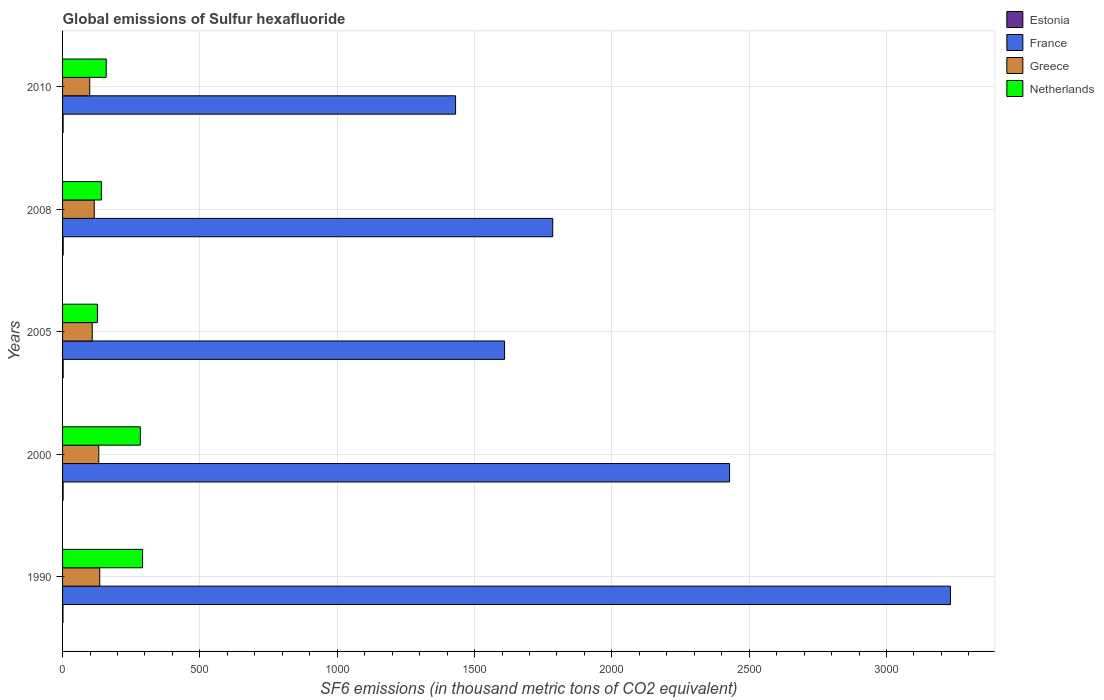How many bars are there on the 1st tick from the top?
Provide a short and direct response. 4. How many bars are there on the 1st tick from the bottom?
Your response must be concise. 4. In how many cases, is the number of bars for a given year not equal to the number of legend labels?
Provide a succinct answer. 0. What is the global emissions of Sulfur hexafluoride in Greece in 2010?
Give a very brief answer. 99. Across all years, what is the maximum global emissions of Sulfur hexafluoride in Estonia?
Your answer should be compact. 2.3. Across all years, what is the minimum global emissions of Sulfur hexafluoride in Greece?
Keep it short and to the point. 99. What is the total global emissions of Sulfur hexafluoride in France in the graph?
Your answer should be very brief. 1.05e+04. What is the difference between the global emissions of Sulfur hexafluoride in Estonia in 2005 and that in 2010?
Keep it short and to the point. 0.2. What is the difference between the global emissions of Sulfur hexafluoride in Netherlands in 2010 and the global emissions of Sulfur hexafluoride in France in 2000?
Make the answer very short. -2269.5. What is the average global emissions of Sulfur hexafluoride in Netherlands per year?
Your response must be concise. 200.32. In the year 2008, what is the difference between the global emissions of Sulfur hexafluoride in Netherlands and global emissions of Sulfur hexafluoride in Estonia?
Your answer should be very brief. 139.1. In how many years, is the global emissions of Sulfur hexafluoride in Estonia greater than 200 thousand metric tons?
Give a very brief answer. 0. What is the ratio of the global emissions of Sulfur hexafluoride in Estonia in 1990 to that in 2000?
Provide a short and direct response. 0.8. Is the global emissions of Sulfur hexafluoride in France in 1990 less than that in 2008?
Your answer should be compact. No. What is the difference between the highest and the second highest global emissions of Sulfur hexafluoride in Netherlands?
Provide a short and direct response. 8.3. What is the difference between the highest and the lowest global emissions of Sulfur hexafluoride in France?
Offer a terse response. 1801.8. In how many years, is the global emissions of Sulfur hexafluoride in France greater than the average global emissions of Sulfur hexafluoride in France taken over all years?
Provide a short and direct response. 2. What does the 4th bar from the top in 1990 represents?
Ensure brevity in your answer.  Estonia. What does the 1st bar from the bottom in 2005 represents?
Keep it short and to the point. Estonia. Is it the case that in every year, the sum of the global emissions of Sulfur hexafluoride in Estonia and global emissions of Sulfur hexafluoride in France is greater than the global emissions of Sulfur hexafluoride in Greece?
Your answer should be very brief. Yes. How many bars are there?
Offer a terse response. 20. How many years are there in the graph?
Provide a short and direct response. 5. Are the values on the major ticks of X-axis written in scientific E-notation?
Make the answer very short. No. Does the graph contain any zero values?
Make the answer very short. No. Does the graph contain grids?
Keep it short and to the point. Yes. Where does the legend appear in the graph?
Your response must be concise. Top right. How many legend labels are there?
Provide a short and direct response. 4. How are the legend labels stacked?
Give a very brief answer. Vertical. What is the title of the graph?
Provide a succinct answer. Global emissions of Sulfur hexafluoride. Does "Italy" appear as one of the legend labels in the graph?
Offer a very short reply. No. What is the label or title of the X-axis?
Offer a very short reply. SF6 emissions (in thousand metric tons of CO2 equivalent). What is the SF6 emissions (in thousand metric tons of CO2 equivalent) in France in 1990?
Offer a very short reply. 3232.8. What is the SF6 emissions (in thousand metric tons of CO2 equivalent) of Greece in 1990?
Your answer should be compact. 135.4. What is the SF6 emissions (in thousand metric tons of CO2 equivalent) of Netherlands in 1990?
Make the answer very short. 291.3. What is the SF6 emissions (in thousand metric tons of CO2 equivalent) of France in 2000?
Your answer should be very brief. 2428.5. What is the SF6 emissions (in thousand metric tons of CO2 equivalent) of Greece in 2000?
Your answer should be compact. 131.8. What is the SF6 emissions (in thousand metric tons of CO2 equivalent) in Netherlands in 2000?
Offer a very short reply. 283. What is the SF6 emissions (in thousand metric tons of CO2 equivalent) of Estonia in 2005?
Give a very brief answer. 2.2. What is the SF6 emissions (in thousand metric tons of CO2 equivalent) in France in 2005?
Provide a short and direct response. 1609.4. What is the SF6 emissions (in thousand metric tons of CO2 equivalent) of Greece in 2005?
Provide a short and direct response. 108.1. What is the SF6 emissions (in thousand metric tons of CO2 equivalent) of Netherlands in 2005?
Ensure brevity in your answer.  126.9. What is the SF6 emissions (in thousand metric tons of CO2 equivalent) of France in 2008?
Keep it short and to the point. 1784.7. What is the SF6 emissions (in thousand metric tons of CO2 equivalent) of Greece in 2008?
Offer a terse response. 115.4. What is the SF6 emissions (in thousand metric tons of CO2 equivalent) of Netherlands in 2008?
Provide a short and direct response. 141.4. What is the SF6 emissions (in thousand metric tons of CO2 equivalent) of France in 2010?
Your answer should be compact. 1431. What is the SF6 emissions (in thousand metric tons of CO2 equivalent) of Greece in 2010?
Your response must be concise. 99. What is the SF6 emissions (in thousand metric tons of CO2 equivalent) in Netherlands in 2010?
Keep it short and to the point. 159. Across all years, what is the maximum SF6 emissions (in thousand metric tons of CO2 equivalent) in France?
Ensure brevity in your answer.  3232.8. Across all years, what is the maximum SF6 emissions (in thousand metric tons of CO2 equivalent) in Greece?
Provide a short and direct response. 135.4. Across all years, what is the maximum SF6 emissions (in thousand metric tons of CO2 equivalent) in Netherlands?
Offer a very short reply. 291.3. Across all years, what is the minimum SF6 emissions (in thousand metric tons of CO2 equivalent) in France?
Make the answer very short. 1431. Across all years, what is the minimum SF6 emissions (in thousand metric tons of CO2 equivalent) in Greece?
Keep it short and to the point. 99. Across all years, what is the minimum SF6 emissions (in thousand metric tons of CO2 equivalent) of Netherlands?
Keep it short and to the point. 126.9. What is the total SF6 emissions (in thousand metric tons of CO2 equivalent) of France in the graph?
Offer a very short reply. 1.05e+04. What is the total SF6 emissions (in thousand metric tons of CO2 equivalent) in Greece in the graph?
Provide a short and direct response. 589.7. What is the total SF6 emissions (in thousand metric tons of CO2 equivalent) in Netherlands in the graph?
Provide a succinct answer. 1001.6. What is the difference between the SF6 emissions (in thousand metric tons of CO2 equivalent) in France in 1990 and that in 2000?
Offer a terse response. 804.3. What is the difference between the SF6 emissions (in thousand metric tons of CO2 equivalent) in Netherlands in 1990 and that in 2000?
Your answer should be compact. 8.3. What is the difference between the SF6 emissions (in thousand metric tons of CO2 equivalent) in Estonia in 1990 and that in 2005?
Your answer should be very brief. -0.6. What is the difference between the SF6 emissions (in thousand metric tons of CO2 equivalent) in France in 1990 and that in 2005?
Provide a succinct answer. 1623.4. What is the difference between the SF6 emissions (in thousand metric tons of CO2 equivalent) of Greece in 1990 and that in 2005?
Make the answer very short. 27.3. What is the difference between the SF6 emissions (in thousand metric tons of CO2 equivalent) of Netherlands in 1990 and that in 2005?
Ensure brevity in your answer.  164.4. What is the difference between the SF6 emissions (in thousand metric tons of CO2 equivalent) of Estonia in 1990 and that in 2008?
Your answer should be compact. -0.7. What is the difference between the SF6 emissions (in thousand metric tons of CO2 equivalent) of France in 1990 and that in 2008?
Offer a very short reply. 1448.1. What is the difference between the SF6 emissions (in thousand metric tons of CO2 equivalent) of Greece in 1990 and that in 2008?
Make the answer very short. 20. What is the difference between the SF6 emissions (in thousand metric tons of CO2 equivalent) of Netherlands in 1990 and that in 2008?
Make the answer very short. 149.9. What is the difference between the SF6 emissions (in thousand metric tons of CO2 equivalent) of France in 1990 and that in 2010?
Offer a terse response. 1801.8. What is the difference between the SF6 emissions (in thousand metric tons of CO2 equivalent) of Greece in 1990 and that in 2010?
Your answer should be very brief. 36.4. What is the difference between the SF6 emissions (in thousand metric tons of CO2 equivalent) in Netherlands in 1990 and that in 2010?
Your response must be concise. 132.3. What is the difference between the SF6 emissions (in thousand metric tons of CO2 equivalent) of France in 2000 and that in 2005?
Ensure brevity in your answer.  819.1. What is the difference between the SF6 emissions (in thousand metric tons of CO2 equivalent) of Greece in 2000 and that in 2005?
Keep it short and to the point. 23.7. What is the difference between the SF6 emissions (in thousand metric tons of CO2 equivalent) in Netherlands in 2000 and that in 2005?
Offer a terse response. 156.1. What is the difference between the SF6 emissions (in thousand metric tons of CO2 equivalent) of France in 2000 and that in 2008?
Keep it short and to the point. 643.8. What is the difference between the SF6 emissions (in thousand metric tons of CO2 equivalent) in Greece in 2000 and that in 2008?
Keep it short and to the point. 16.4. What is the difference between the SF6 emissions (in thousand metric tons of CO2 equivalent) in Netherlands in 2000 and that in 2008?
Ensure brevity in your answer.  141.6. What is the difference between the SF6 emissions (in thousand metric tons of CO2 equivalent) of Estonia in 2000 and that in 2010?
Provide a short and direct response. 0. What is the difference between the SF6 emissions (in thousand metric tons of CO2 equivalent) of France in 2000 and that in 2010?
Give a very brief answer. 997.5. What is the difference between the SF6 emissions (in thousand metric tons of CO2 equivalent) in Greece in 2000 and that in 2010?
Provide a short and direct response. 32.8. What is the difference between the SF6 emissions (in thousand metric tons of CO2 equivalent) of Netherlands in 2000 and that in 2010?
Offer a very short reply. 124. What is the difference between the SF6 emissions (in thousand metric tons of CO2 equivalent) in Estonia in 2005 and that in 2008?
Your response must be concise. -0.1. What is the difference between the SF6 emissions (in thousand metric tons of CO2 equivalent) in France in 2005 and that in 2008?
Keep it short and to the point. -175.3. What is the difference between the SF6 emissions (in thousand metric tons of CO2 equivalent) of Greece in 2005 and that in 2008?
Your response must be concise. -7.3. What is the difference between the SF6 emissions (in thousand metric tons of CO2 equivalent) of Estonia in 2005 and that in 2010?
Provide a succinct answer. 0.2. What is the difference between the SF6 emissions (in thousand metric tons of CO2 equivalent) in France in 2005 and that in 2010?
Make the answer very short. 178.4. What is the difference between the SF6 emissions (in thousand metric tons of CO2 equivalent) of Netherlands in 2005 and that in 2010?
Your answer should be compact. -32.1. What is the difference between the SF6 emissions (in thousand metric tons of CO2 equivalent) in Estonia in 2008 and that in 2010?
Give a very brief answer. 0.3. What is the difference between the SF6 emissions (in thousand metric tons of CO2 equivalent) in France in 2008 and that in 2010?
Your answer should be very brief. 353.7. What is the difference between the SF6 emissions (in thousand metric tons of CO2 equivalent) of Greece in 2008 and that in 2010?
Ensure brevity in your answer.  16.4. What is the difference between the SF6 emissions (in thousand metric tons of CO2 equivalent) in Netherlands in 2008 and that in 2010?
Your answer should be compact. -17.6. What is the difference between the SF6 emissions (in thousand metric tons of CO2 equivalent) of Estonia in 1990 and the SF6 emissions (in thousand metric tons of CO2 equivalent) of France in 2000?
Offer a very short reply. -2426.9. What is the difference between the SF6 emissions (in thousand metric tons of CO2 equivalent) in Estonia in 1990 and the SF6 emissions (in thousand metric tons of CO2 equivalent) in Greece in 2000?
Make the answer very short. -130.2. What is the difference between the SF6 emissions (in thousand metric tons of CO2 equivalent) of Estonia in 1990 and the SF6 emissions (in thousand metric tons of CO2 equivalent) of Netherlands in 2000?
Give a very brief answer. -281.4. What is the difference between the SF6 emissions (in thousand metric tons of CO2 equivalent) in France in 1990 and the SF6 emissions (in thousand metric tons of CO2 equivalent) in Greece in 2000?
Offer a very short reply. 3101. What is the difference between the SF6 emissions (in thousand metric tons of CO2 equivalent) in France in 1990 and the SF6 emissions (in thousand metric tons of CO2 equivalent) in Netherlands in 2000?
Your answer should be compact. 2949.8. What is the difference between the SF6 emissions (in thousand metric tons of CO2 equivalent) of Greece in 1990 and the SF6 emissions (in thousand metric tons of CO2 equivalent) of Netherlands in 2000?
Ensure brevity in your answer.  -147.6. What is the difference between the SF6 emissions (in thousand metric tons of CO2 equivalent) in Estonia in 1990 and the SF6 emissions (in thousand metric tons of CO2 equivalent) in France in 2005?
Ensure brevity in your answer.  -1607.8. What is the difference between the SF6 emissions (in thousand metric tons of CO2 equivalent) in Estonia in 1990 and the SF6 emissions (in thousand metric tons of CO2 equivalent) in Greece in 2005?
Your response must be concise. -106.5. What is the difference between the SF6 emissions (in thousand metric tons of CO2 equivalent) in Estonia in 1990 and the SF6 emissions (in thousand metric tons of CO2 equivalent) in Netherlands in 2005?
Provide a short and direct response. -125.3. What is the difference between the SF6 emissions (in thousand metric tons of CO2 equivalent) in France in 1990 and the SF6 emissions (in thousand metric tons of CO2 equivalent) in Greece in 2005?
Ensure brevity in your answer.  3124.7. What is the difference between the SF6 emissions (in thousand metric tons of CO2 equivalent) in France in 1990 and the SF6 emissions (in thousand metric tons of CO2 equivalent) in Netherlands in 2005?
Provide a short and direct response. 3105.9. What is the difference between the SF6 emissions (in thousand metric tons of CO2 equivalent) of Estonia in 1990 and the SF6 emissions (in thousand metric tons of CO2 equivalent) of France in 2008?
Your response must be concise. -1783.1. What is the difference between the SF6 emissions (in thousand metric tons of CO2 equivalent) in Estonia in 1990 and the SF6 emissions (in thousand metric tons of CO2 equivalent) in Greece in 2008?
Provide a short and direct response. -113.8. What is the difference between the SF6 emissions (in thousand metric tons of CO2 equivalent) in Estonia in 1990 and the SF6 emissions (in thousand metric tons of CO2 equivalent) in Netherlands in 2008?
Give a very brief answer. -139.8. What is the difference between the SF6 emissions (in thousand metric tons of CO2 equivalent) of France in 1990 and the SF6 emissions (in thousand metric tons of CO2 equivalent) of Greece in 2008?
Offer a terse response. 3117.4. What is the difference between the SF6 emissions (in thousand metric tons of CO2 equivalent) of France in 1990 and the SF6 emissions (in thousand metric tons of CO2 equivalent) of Netherlands in 2008?
Make the answer very short. 3091.4. What is the difference between the SF6 emissions (in thousand metric tons of CO2 equivalent) in Estonia in 1990 and the SF6 emissions (in thousand metric tons of CO2 equivalent) in France in 2010?
Offer a very short reply. -1429.4. What is the difference between the SF6 emissions (in thousand metric tons of CO2 equivalent) of Estonia in 1990 and the SF6 emissions (in thousand metric tons of CO2 equivalent) of Greece in 2010?
Your answer should be compact. -97.4. What is the difference between the SF6 emissions (in thousand metric tons of CO2 equivalent) of Estonia in 1990 and the SF6 emissions (in thousand metric tons of CO2 equivalent) of Netherlands in 2010?
Your response must be concise. -157.4. What is the difference between the SF6 emissions (in thousand metric tons of CO2 equivalent) in France in 1990 and the SF6 emissions (in thousand metric tons of CO2 equivalent) in Greece in 2010?
Give a very brief answer. 3133.8. What is the difference between the SF6 emissions (in thousand metric tons of CO2 equivalent) of France in 1990 and the SF6 emissions (in thousand metric tons of CO2 equivalent) of Netherlands in 2010?
Keep it short and to the point. 3073.8. What is the difference between the SF6 emissions (in thousand metric tons of CO2 equivalent) of Greece in 1990 and the SF6 emissions (in thousand metric tons of CO2 equivalent) of Netherlands in 2010?
Your answer should be very brief. -23.6. What is the difference between the SF6 emissions (in thousand metric tons of CO2 equivalent) of Estonia in 2000 and the SF6 emissions (in thousand metric tons of CO2 equivalent) of France in 2005?
Offer a terse response. -1607.4. What is the difference between the SF6 emissions (in thousand metric tons of CO2 equivalent) in Estonia in 2000 and the SF6 emissions (in thousand metric tons of CO2 equivalent) in Greece in 2005?
Offer a very short reply. -106.1. What is the difference between the SF6 emissions (in thousand metric tons of CO2 equivalent) in Estonia in 2000 and the SF6 emissions (in thousand metric tons of CO2 equivalent) in Netherlands in 2005?
Offer a terse response. -124.9. What is the difference between the SF6 emissions (in thousand metric tons of CO2 equivalent) in France in 2000 and the SF6 emissions (in thousand metric tons of CO2 equivalent) in Greece in 2005?
Your response must be concise. 2320.4. What is the difference between the SF6 emissions (in thousand metric tons of CO2 equivalent) in France in 2000 and the SF6 emissions (in thousand metric tons of CO2 equivalent) in Netherlands in 2005?
Provide a succinct answer. 2301.6. What is the difference between the SF6 emissions (in thousand metric tons of CO2 equivalent) in Greece in 2000 and the SF6 emissions (in thousand metric tons of CO2 equivalent) in Netherlands in 2005?
Your answer should be very brief. 4.9. What is the difference between the SF6 emissions (in thousand metric tons of CO2 equivalent) in Estonia in 2000 and the SF6 emissions (in thousand metric tons of CO2 equivalent) in France in 2008?
Your response must be concise. -1782.7. What is the difference between the SF6 emissions (in thousand metric tons of CO2 equivalent) in Estonia in 2000 and the SF6 emissions (in thousand metric tons of CO2 equivalent) in Greece in 2008?
Ensure brevity in your answer.  -113.4. What is the difference between the SF6 emissions (in thousand metric tons of CO2 equivalent) of Estonia in 2000 and the SF6 emissions (in thousand metric tons of CO2 equivalent) of Netherlands in 2008?
Make the answer very short. -139.4. What is the difference between the SF6 emissions (in thousand metric tons of CO2 equivalent) of France in 2000 and the SF6 emissions (in thousand metric tons of CO2 equivalent) of Greece in 2008?
Ensure brevity in your answer.  2313.1. What is the difference between the SF6 emissions (in thousand metric tons of CO2 equivalent) of France in 2000 and the SF6 emissions (in thousand metric tons of CO2 equivalent) of Netherlands in 2008?
Make the answer very short. 2287.1. What is the difference between the SF6 emissions (in thousand metric tons of CO2 equivalent) of Estonia in 2000 and the SF6 emissions (in thousand metric tons of CO2 equivalent) of France in 2010?
Your answer should be very brief. -1429. What is the difference between the SF6 emissions (in thousand metric tons of CO2 equivalent) in Estonia in 2000 and the SF6 emissions (in thousand metric tons of CO2 equivalent) in Greece in 2010?
Provide a short and direct response. -97. What is the difference between the SF6 emissions (in thousand metric tons of CO2 equivalent) in Estonia in 2000 and the SF6 emissions (in thousand metric tons of CO2 equivalent) in Netherlands in 2010?
Make the answer very short. -157. What is the difference between the SF6 emissions (in thousand metric tons of CO2 equivalent) in France in 2000 and the SF6 emissions (in thousand metric tons of CO2 equivalent) in Greece in 2010?
Provide a short and direct response. 2329.5. What is the difference between the SF6 emissions (in thousand metric tons of CO2 equivalent) in France in 2000 and the SF6 emissions (in thousand metric tons of CO2 equivalent) in Netherlands in 2010?
Your response must be concise. 2269.5. What is the difference between the SF6 emissions (in thousand metric tons of CO2 equivalent) of Greece in 2000 and the SF6 emissions (in thousand metric tons of CO2 equivalent) of Netherlands in 2010?
Ensure brevity in your answer.  -27.2. What is the difference between the SF6 emissions (in thousand metric tons of CO2 equivalent) in Estonia in 2005 and the SF6 emissions (in thousand metric tons of CO2 equivalent) in France in 2008?
Keep it short and to the point. -1782.5. What is the difference between the SF6 emissions (in thousand metric tons of CO2 equivalent) of Estonia in 2005 and the SF6 emissions (in thousand metric tons of CO2 equivalent) of Greece in 2008?
Your answer should be compact. -113.2. What is the difference between the SF6 emissions (in thousand metric tons of CO2 equivalent) in Estonia in 2005 and the SF6 emissions (in thousand metric tons of CO2 equivalent) in Netherlands in 2008?
Offer a terse response. -139.2. What is the difference between the SF6 emissions (in thousand metric tons of CO2 equivalent) in France in 2005 and the SF6 emissions (in thousand metric tons of CO2 equivalent) in Greece in 2008?
Provide a succinct answer. 1494. What is the difference between the SF6 emissions (in thousand metric tons of CO2 equivalent) of France in 2005 and the SF6 emissions (in thousand metric tons of CO2 equivalent) of Netherlands in 2008?
Give a very brief answer. 1468. What is the difference between the SF6 emissions (in thousand metric tons of CO2 equivalent) in Greece in 2005 and the SF6 emissions (in thousand metric tons of CO2 equivalent) in Netherlands in 2008?
Ensure brevity in your answer.  -33.3. What is the difference between the SF6 emissions (in thousand metric tons of CO2 equivalent) of Estonia in 2005 and the SF6 emissions (in thousand metric tons of CO2 equivalent) of France in 2010?
Provide a short and direct response. -1428.8. What is the difference between the SF6 emissions (in thousand metric tons of CO2 equivalent) of Estonia in 2005 and the SF6 emissions (in thousand metric tons of CO2 equivalent) of Greece in 2010?
Offer a very short reply. -96.8. What is the difference between the SF6 emissions (in thousand metric tons of CO2 equivalent) in Estonia in 2005 and the SF6 emissions (in thousand metric tons of CO2 equivalent) in Netherlands in 2010?
Your response must be concise. -156.8. What is the difference between the SF6 emissions (in thousand metric tons of CO2 equivalent) in France in 2005 and the SF6 emissions (in thousand metric tons of CO2 equivalent) in Greece in 2010?
Offer a terse response. 1510.4. What is the difference between the SF6 emissions (in thousand metric tons of CO2 equivalent) in France in 2005 and the SF6 emissions (in thousand metric tons of CO2 equivalent) in Netherlands in 2010?
Keep it short and to the point. 1450.4. What is the difference between the SF6 emissions (in thousand metric tons of CO2 equivalent) of Greece in 2005 and the SF6 emissions (in thousand metric tons of CO2 equivalent) of Netherlands in 2010?
Your answer should be very brief. -50.9. What is the difference between the SF6 emissions (in thousand metric tons of CO2 equivalent) in Estonia in 2008 and the SF6 emissions (in thousand metric tons of CO2 equivalent) in France in 2010?
Ensure brevity in your answer.  -1428.7. What is the difference between the SF6 emissions (in thousand metric tons of CO2 equivalent) of Estonia in 2008 and the SF6 emissions (in thousand metric tons of CO2 equivalent) of Greece in 2010?
Keep it short and to the point. -96.7. What is the difference between the SF6 emissions (in thousand metric tons of CO2 equivalent) of Estonia in 2008 and the SF6 emissions (in thousand metric tons of CO2 equivalent) of Netherlands in 2010?
Keep it short and to the point. -156.7. What is the difference between the SF6 emissions (in thousand metric tons of CO2 equivalent) in France in 2008 and the SF6 emissions (in thousand metric tons of CO2 equivalent) in Greece in 2010?
Provide a short and direct response. 1685.7. What is the difference between the SF6 emissions (in thousand metric tons of CO2 equivalent) of France in 2008 and the SF6 emissions (in thousand metric tons of CO2 equivalent) of Netherlands in 2010?
Give a very brief answer. 1625.7. What is the difference between the SF6 emissions (in thousand metric tons of CO2 equivalent) of Greece in 2008 and the SF6 emissions (in thousand metric tons of CO2 equivalent) of Netherlands in 2010?
Your answer should be very brief. -43.6. What is the average SF6 emissions (in thousand metric tons of CO2 equivalent) of Estonia per year?
Give a very brief answer. 2.02. What is the average SF6 emissions (in thousand metric tons of CO2 equivalent) of France per year?
Your response must be concise. 2097.28. What is the average SF6 emissions (in thousand metric tons of CO2 equivalent) of Greece per year?
Provide a short and direct response. 117.94. What is the average SF6 emissions (in thousand metric tons of CO2 equivalent) in Netherlands per year?
Keep it short and to the point. 200.32. In the year 1990, what is the difference between the SF6 emissions (in thousand metric tons of CO2 equivalent) in Estonia and SF6 emissions (in thousand metric tons of CO2 equivalent) in France?
Ensure brevity in your answer.  -3231.2. In the year 1990, what is the difference between the SF6 emissions (in thousand metric tons of CO2 equivalent) in Estonia and SF6 emissions (in thousand metric tons of CO2 equivalent) in Greece?
Give a very brief answer. -133.8. In the year 1990, what is the difference between the SF6 emissions (in thousand metric tons of CO2 equivalent) in Estonia and SF6 emissions (in thousand metric tons of CO2 equivalent) in Netherlands?
Ensure brevity in your answer.  -289.7. In the year 1990, what is the difference between the SF6 emissions (in thousand metric tons of CO2 equivalent) in France and SF6 emissions (in thousand metric tons of CO2 equivalent) in Greece?
Offer a very short reply. 3097.4. In the year 1990, what is the difference between the SF6 emissions (in thousand metric tons of CO2 equivalent) of France and SF6 emissions (in thousand metric tons of CO2 equivalent) of Netherlands?
Offer a very short reply. 2941.5. In the year 1990, what is the difference between the SF6 emissions (in thousand metric tons of CO2 equivalent) in Greece and SF6 emissions (in thousand metric tons of CO2 equivalent) in Netherlands?
Ensure brevity in your answer.  -155.9. In the year 2000, what is the difference between the SF6 emissions (in thousand metric tons of CO2 equivalent) of Estonia and SF6 emissions (in thousand metric tons of CO2 equivalent) of France?
Keep it short and to the point. -2426.5. In the year 2000, what is the difference between the SF6 emissions (in thousand metric tons of CO2 equivalent) of Estonia and SF6 emissions (in thousand metric tons of CO2 equivalent) of Greece?
Provide a short and direct response. -129.8. In the year 2000, what is the difference between the SF6 emissions (in thousand metric tons of CO2 equivalent) in Estonia and SF6 emissions (in thousand metric tons of CO2 equivalent) in Netherlands?
Offer a terse response. -281. In the year 2000, what is the difference between the SF6 emissions (in thousand metric tons of CO2 equivalent) of France and SF6 emissions (in thousand metric tons of CO2 equivalent) of Greece?
Provide a short and direct response. 2296.7. In the year 2000, what is the difference between the SF6 emissions (in thousand metric tons of CO2 equivalent) in France and SF6 emissions (in thousand metric tons of CO2 equivalent) in Netherlands?
Offer a very short reply. 2145.5. In the year 2000, what is the difference between the SF6 emissions (in thousand metric tons of CO2 equivalent) in Greece and SF6 emissions (in thousand metric tons of CO2 equivalent) in Netherlands?
Your answer should be very brief. -151.2. In the year 2005, what is the difference between the SF6 emissions (in thousand metric tons of CO2 equivalent) of Estonia and SF6 emissions (in thousand metric tons of CO2 equivalent) of France?
Keep it short and to the point. -1607.2. In the year 2005, what is the difference between the SF6 emissions (in thousand metric tons of CO2 equivalent) of Estonia and SF6 emissions (in thousand metric tons of CO2 equivalent) of Greece?
Provide a succinct answer. -105.9. In the year 2005, what is the difference between the SF6 emissions (in thousand metric tons of CO2 equivalent) of Estonia and SF6 emissions (in thousand metric tons of CO2 equivalent) of Netherlands?
Ensure brevity in your answer.  -124.7. In the year 2005, what is the difference between the SF6 emissions (in thousand metric tons of CO2 equivalent) in France and SF6 emissions (in thousand metric tons of CO2 equivalent) in Greece?
Ensure brevity in your answer.  1501.3. In the year 2005, what is the difference between the SF6 emissions (in thousand metric tons of CO2 equivalent) of France and SF6 emissions (in thousand metric tons of CO2 equivalent) of Netherlands?
Give a very brief answer. 1482.5. In the year 2005, what is the difference between the SF6 emissions (in thousand metric tons of CO2 equivalent) in Greece and SF6 emissions (in thousand metric tons of CO2 equivalent) in Netherlands?
Give a very brief answer. -18.8. In the year 2008, what is the difference between the SF6 emissions (in thousand metric tons of CO2 equivalent) in Estonia and SF6 emissions (in thousand metric tons of CO2 equivalent) in France?
Offer a very short reply. -1782.4. In the year 2008, what is the difference between the SF6 emissions (in thousand metric tons of CO2 equivalent) in Estonia and SF6 emissions (in thousand metric tons of CO2 equivalent) in Greece?
Your response must be concise. -113.1. In the year 2008, what is the difference between the SF6 emissions (in thousand metric tons of CO2 equivalent) of Estonia and SF6 emissions (in thousand metric tons of CO2 equivalent) of Netherlands?
Offer a terse response. -139.1. In the year 2008, what is the difference between the SF6 emissions (in thousand metric tons of CO2 equivalent) in France and SF6 emissions (in thousand metric tons of CO2 equivalent) in Greece?
Your answer should be very brief. 1669.3. In the year 2008, what is the difference between the SF6 emissions (in thousand metric tons of CO2 equivalent) in France and SF6 emissions (in thousand metric tons of CO2 equivalent) in Netherlands?
Your response must be concise. 1643.3. In the year 2008, what is the difference between the SF6 emissions (in thousand metric tons of CO2 equivalent) in Greece and SF6 emissions (in thousand metric tons of CO2 equivalent) in Netherlands?
Provide a short and direct response. -26. In the year 2010, what is the difference between the SF6 emissions (in thousand metric tons of CO2 equivalent) of Estonia and SF6 emissions (in thousand metric tons of CO2 equivalent) of France?
Provide a succinct answer. -1429. In the year 2010, what is the difference between the SF6 emissions (in thousand metric tons of CO2 equivalent) of Estonia and SF6 emissions (in thousand metric tons of CO2 equivalent) of Greece?
Offer a very short reply. -97. In the year 2010, what is the difference between the SF6 emissions (in thousand metric tons of CO2 equivalent) of Estonia and SF6 emissions (in thousand metric tons of CO2 equivalent) of Netherlands?
Ensure brevity in your answer.  -157. In the year 2010, what is the difference between the SF6 emissions (in thousand metric tons of CO2 equivalent) in France and SF6 emissions (in thousand metric tons of CO2 equivalent) in Greece?
Ensure brevity in your answer.  1332. In the year 2010, what is the difference between the SF6 emissions (in thousand metric tons of CO2 equivalent) of France and SF6 emissions (in thousand metric tons of CO2 equivalent) of Netherlands?
Provide a short and direct response. 1272. In the year 2010, what is the difference between the SF6 emissions (in thousand metric tons of CO2 equivalent) in Greece and SF6 emissions (in thousand metric tons of CO2 equivalent) in Netherlands?
Ensure brevity in your answer.  -60. What is the ratio of the SF6 emissions (in thousand metric tons of CO2 equivalent) of Estonia in 1990 to that in 2000?
Ensure brevity in your answer.  0.8. What is the ratio of the SF6 emissions (in thousand metric tons of CO2 equivalent) of France in 1990 to that in 2000?
Give a very brief answer. 1.33. What is the ratio of the SF6 emissions (in thousand metric tons of CO2 equivalent) in Greece in 1990 to that in 2000?
Your answer should be very brief. 1.03. What is the ratio of the SF6 emissions (in thousand metric tons of CO2 equivalent) of Netherlands in 1990 to that in 2000?
Keep it short and to the point. 1.03. What is the ratio of the SF6 emissions (in thousand metric tons of CO2 equivalent) in Estonia in 1990 to that in 2005?
Make the answer very short. 0.73. What is the ratio of the SF6 emissions (in thousand metric tons of CO2 equivalent) of France in 1990 to that in 2005?
Your answer should be compact. 2.01. What is the ratio of the SF6 emissions (in thousand metric tons of CO2 equivalent) in Greece in 1990 to that in 2005?
Keep it short and to the point. 1.25. What is the ratio of the SF6 emissions (in thousand metric tons of CO2 equivalent) in Netherlands in 1990 to that in 2005?
Ensure brevity in your answer.  2.3. What is the ratio of the SF6 emissions (in thousand metric tons of CO2 equivalent) of Estonia in 1990 to that in 2008?
Your response must be concise. 0.7. What is the ratio of the SF6 emissions (in thousand metric tons of CO2 equivalent) in France in 1990 to that in 2008?
Provide a succinct answer. 1.81. What is the ratio of the SF6 emissions (in thousand metric tons of CO2 equivalent) of Greece in 1990 to that in 2008?
Offer a very short reply. 1.17. What is the ratio of the SF6 emissions (in thousand metric tons of CO2 equivalent) of Netherlands in 1990 to that in 2008?
Provide a succinct answer. 2.06. What is the ratio of the SF6 emissions (in thousand metric tons of CO2 equivalent) of France in 1990 to that in 2010?
Give a very brief answer. 2.26. What is the ratio of the SF6 emissions (in thousand metric tons of CO2 equivalent) of Greece in 1990 to that in 2010?
Your response must be concise. 1.37. What is the ratio of the SF6 emissions (in thousand metric tons of CO2 equivalent) in Netherlands in 1990 to that in 2010?
Keep it short and to the point. 1.83. What is the ratio of the SF6 emissions (in thousand metric tons of CO2 equivalent) in France in 2000 to that in 2005?
Your answer should be very brief. 1.51. What is the ratio of the SF6 emissions (in thousand metric tons of CO2 equivalent) in Greece in 2000 to that in 2005?
Your answer should be compact. 1.22. What is the ratio of the SF6 emissions (in thousand metric tons of CO2 equivalent) of Netherlands in 2000 to that in 2005?
Give a very brief answer. 2.23. What is the ratio of the SF6 emissions (in thousand metric tons of CO2 equivalent) in Estonia in 2000 to that in 2008?
Your response must be concise. 0.87. What is the ratio of the SF6 emissions (in thousand metric tons of CO2 equivalent) in France in 2000 to that in 2008?
Your response must be concise. 1.36. What is the ratio of the SF6 emissions (in thousand metric tons of CO2 equivalent) in Greece in 2000 to that in 2008?
Ensure brevity in your answer.  1.14. What is the ratio of the SF6 emissions (in thousand metric tons of CO2 equivalent) of Netherlands in 2000 to that in 2008?
Make the answer very short. 2. What is the ratio of the SF6 emissions (in thousand metric tons of CO2 equivalent) in Estonia in 2000 to that in 2010?
Your response must be concise. 1. What is the ratio of the SF6 emissions (in thousand metric tons of CO2 equivalent) of France in 2000 to that in 2010?
Your answer should be very brief. 1.7. What is the ratio of the SF6 emissions (in thousand metric tons of CO2 equivalent) of Greece in 2000 to that in 2010?
Your answer should be very brief. 1.33. What is the ratio of the SF6 emissions (in thousand metric tons of CO2 equivalent) of Netherlands in 2000 to that in 2010?
Your answer should be compact. 1.78. What is the ratio of the SF6 emissions (in thousand metric tons of CO2 equivalent) in Estonia in 2005 to that in 2008?
Provide a short and direct response. 0.96. What is the ratio of the SF6 emissions (in thousand metric tons of CO2 equivalent) in France in 2005 to that in 2008?
Offer a terse response. 0.9. What is the ratio of the SF6 emissions (in thousand metric tons of CO2 equivalent) of Greece in 2005 to that in 2008?
Your response must be concise. 0.94. What is the ratio of the SF6 emissions (in thousand metric tons of CO2 equivalent) of Netherlands in 2005 to that in 2008?
Keep it short and to the point. 0.9. What is the ratio of the SF6 emissions (in thousand metric tons of CO2 equivalent) of France in 2005 to that in 2010?
Your response must be concise. 1.12. What is the ratio of the SF6 emissions (in thousand metric tons of CO2 equivalent) in Greece in 2005 to that in 2010?
Your response must be concise. 1.09. What is the ratio of the SF6 emissions (in thousand metric tons of CO2 equivalent) of Netherlands in 2005 to that in 2010?
Your response must be concise. 0.8. What is the ratio of the SF6 emissions (in thousand metric tons of CO2 equivalent) in Estonia in 2008 to that in 2010?
Keep it short and to the point. 1.15. What is the ratio of the SF6 emissions (in thousand metric tons of CO2 equivalent) of France in 2008 to that in 2010?
Make the answer very short. 1.25. What is the ratio of the SF6 emissions (in thousand metric tons of CO2 equivalent) in Greece in 2008 to that in 2010?
Provide a short and direct response. 1.17. What is the ratio of the SF6 emissions (in thousand metric tons of CO2 equivalent) in Netherlands in 2008 to that in 2010?
Your response must be concise. 0.89. What is the difference between the highest and the second highest SF6 emissions (in thousand metric tons of CO2 equivalent) in France?
Provide a succinct answer. 804.3. What is the difference between the highest and the lowest SF6 emissions (in thousand metric tons of CO2 equivalent) in France?
Ensure brevity in your answer.  1801.8. What is the difference between the highest and the lowest SF6 emissions (in thousand metric tons of CO2 equivalent) of Greece?
Ensure brevity in your answer.  36.4. What is the difference between the highest and the lowest SF6 emissions (in thousand metric tons of CO2 equivalent) of Netherlands?
Provide a short and direct response. 164.4. 